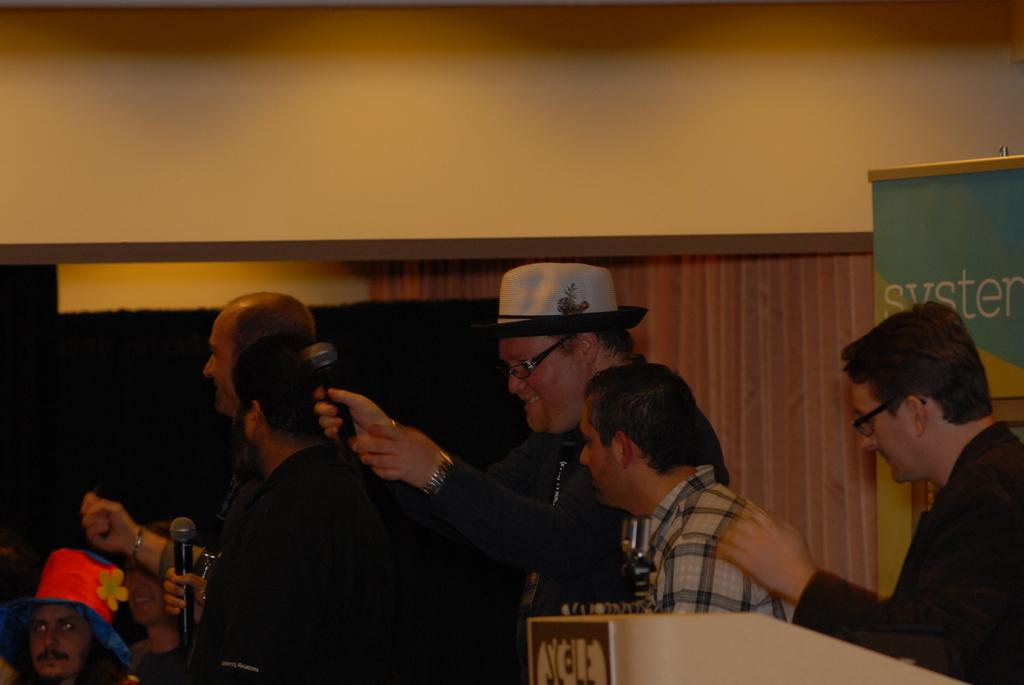How many people are in the image? There is a group of persons in the image. What are some of the persons doing in the image? Some of the persons are holding microphones. What can be seen in the background of the image? There is a wall, additional persons, and a banner in the background of the image. What type of potato is being used as a prop in the image? There is no potato present in the image. Is it raining in the image? The image does not show any indication of rain. 